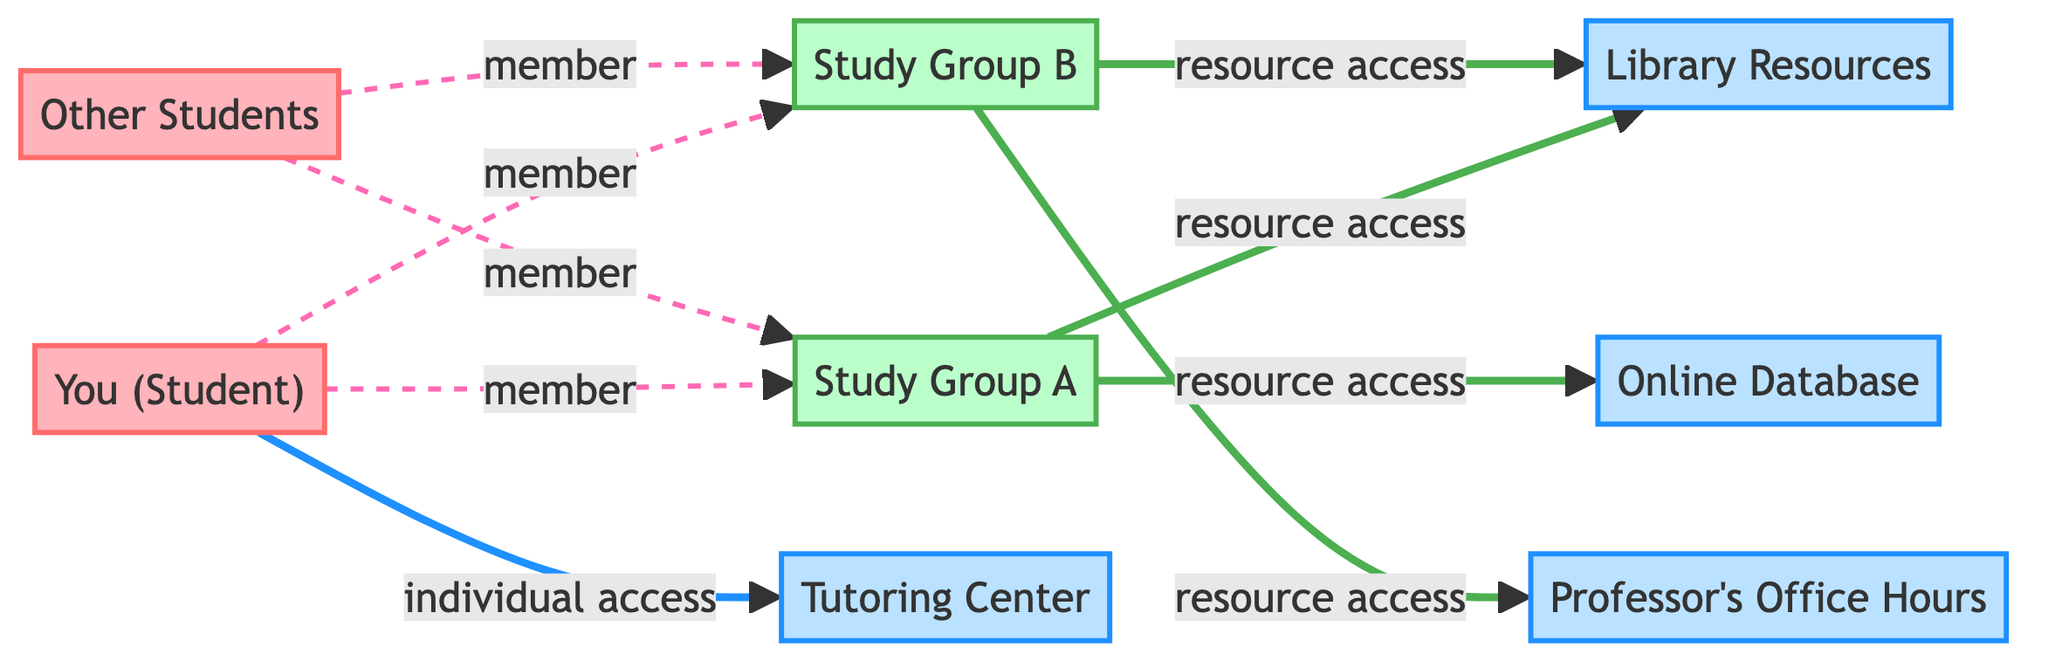What is the total number of nodes in the diagram? The diagram lists 8 distinct entities, which include individuals, groups, and resources that are represented as nodes. Counting these entities gives us a total of 8 nodes.
Answer: 8 How many groups are present in the diagram? There are two distinct groups mentioned in the diagram: Study Group A and Study Group B. Counting these yields a total of 2 groups.
Answer: 2 Which resources can Study Group A access? According to the diagram, Study Group A has access to Library Resources and Online Database. These are the two resources connected to Study Group A.
Answer: Library Resources, Online Database What is the relationship type between "You (Student)" and "Study Group A"? The relationship type indicated between "You (Student)" and "Study Group A" is a 'member' relationship, which signifies that the student is part of this study group.
Answer: member How many resources does "You (Student)" have direct access to? The diagram shows one direct connection where "You (Student)" has access to the Tutoring Center. Therefore, the total number of resources accessed by the student is 1.
Answer: 1 Which resource is uniquely accessible to Study Group B? Study Group B has a unique resource access to Professor's Office Hours, while Study Group A does not share this resource. This indicates that Study Group B has exclusive access to it.
Answer: Professor's Office Hours What type of connections exist for "Other Students" in the diagram? "Other Students" have member connections established with both Study Group A and Study Group B, which illustrates their participation in these groups.
Answer: member Which individual has the most direct connections to resources? The student, labeled "You (Student)", has connections leading to resources via direct access to the Tutoring Center and indirect access to resources through the study groups. Thus, "You (Student)" have the most connections.
Answer: You (Student) 